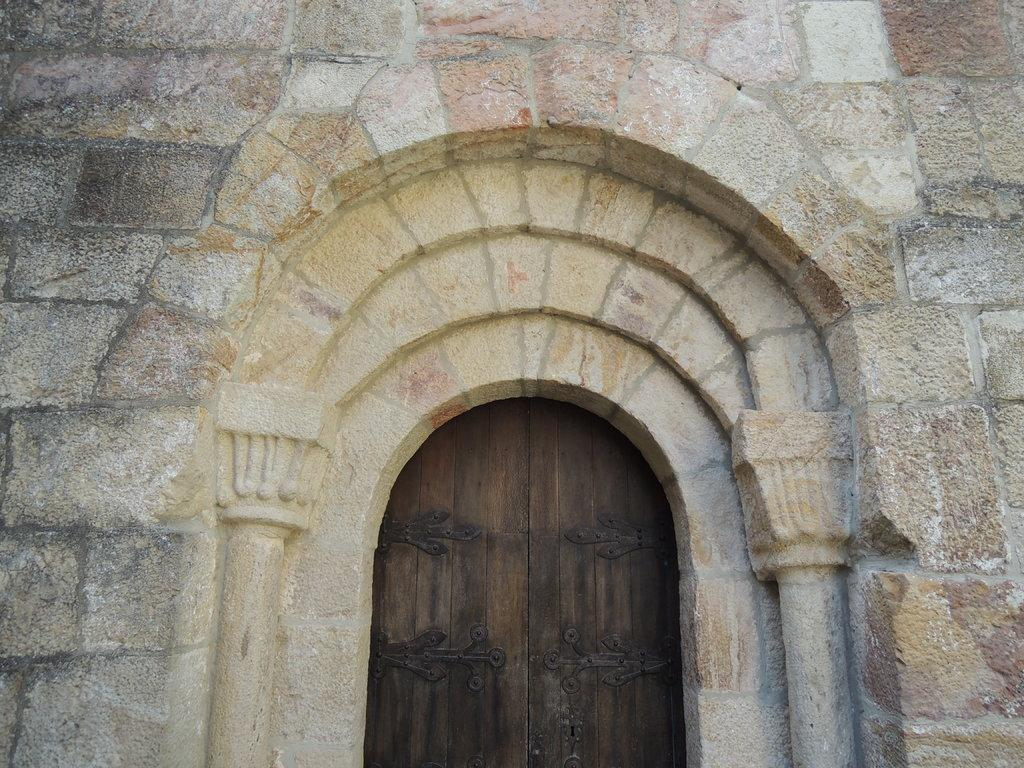What type of structure is visible in the image? There is a building in the image. What material is the door of the building made of? The door of the building is made of wood. How many legs can be seen supporting the building in the image? There are no legs visible in the image; the building is likely resting on a foundation or a slab. 